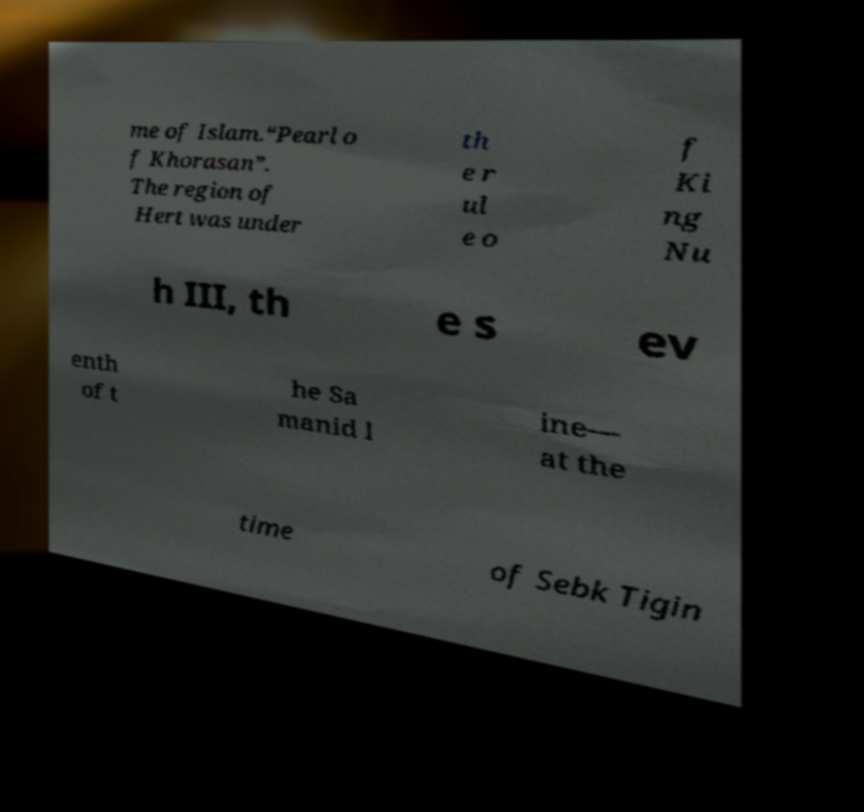Could you extract and type out the text from this image? me of Islam.“Pearl o f Khorasan”. The region of Hert was under th e r ul e o f Ki ng Nu h III, th e s ev enth of t he Sa manid l ine— at the time of Sebk Tigin 